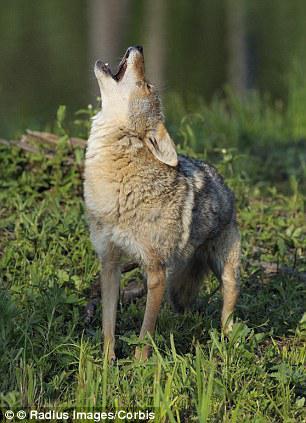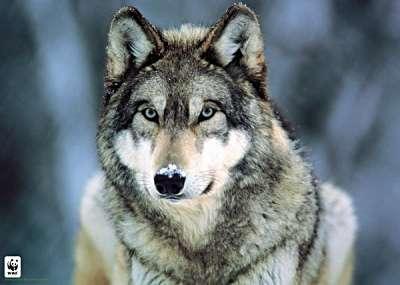The first image is the image on the left, the second image is the image on the right. Analyze the images presented: Is the assertion "The wolves are looking toward the camera." valid? Answer yes or no. No. The first image is the image on the left, the second image is the image on the right. For the images displayed, is the sentence "the wolves in the image pair are looking into the camera" factually correct? Answer yes or no. No. 